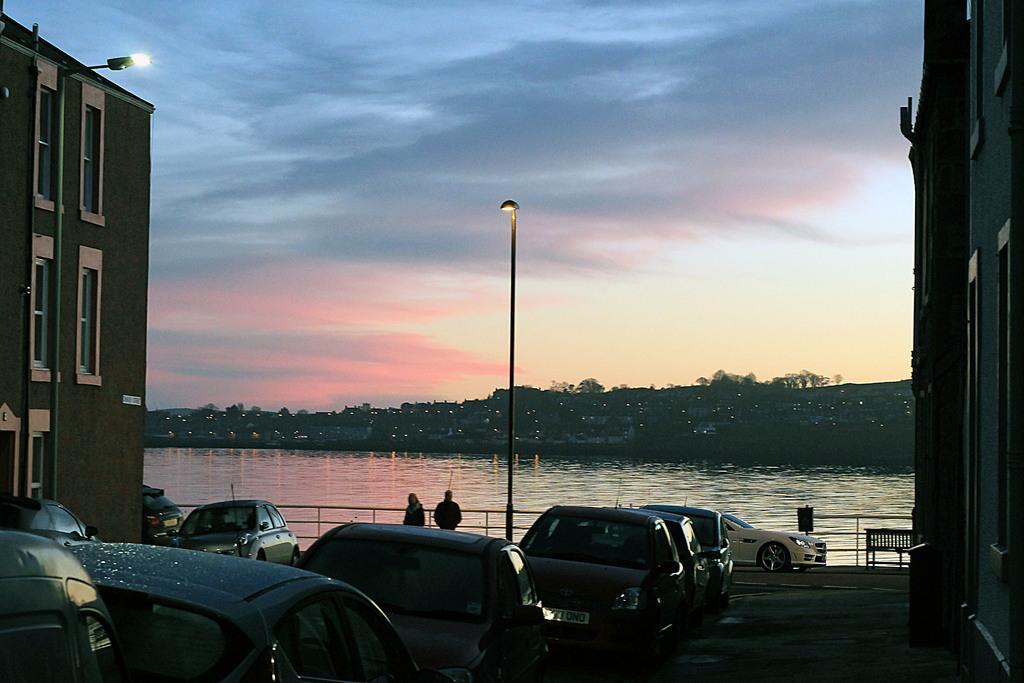Can you describe this image briefly? In this picture I can see buildings and a pole light and I can see light to the building and I can see cars parked and water and a blue cloudy sky and couple of them standing. 